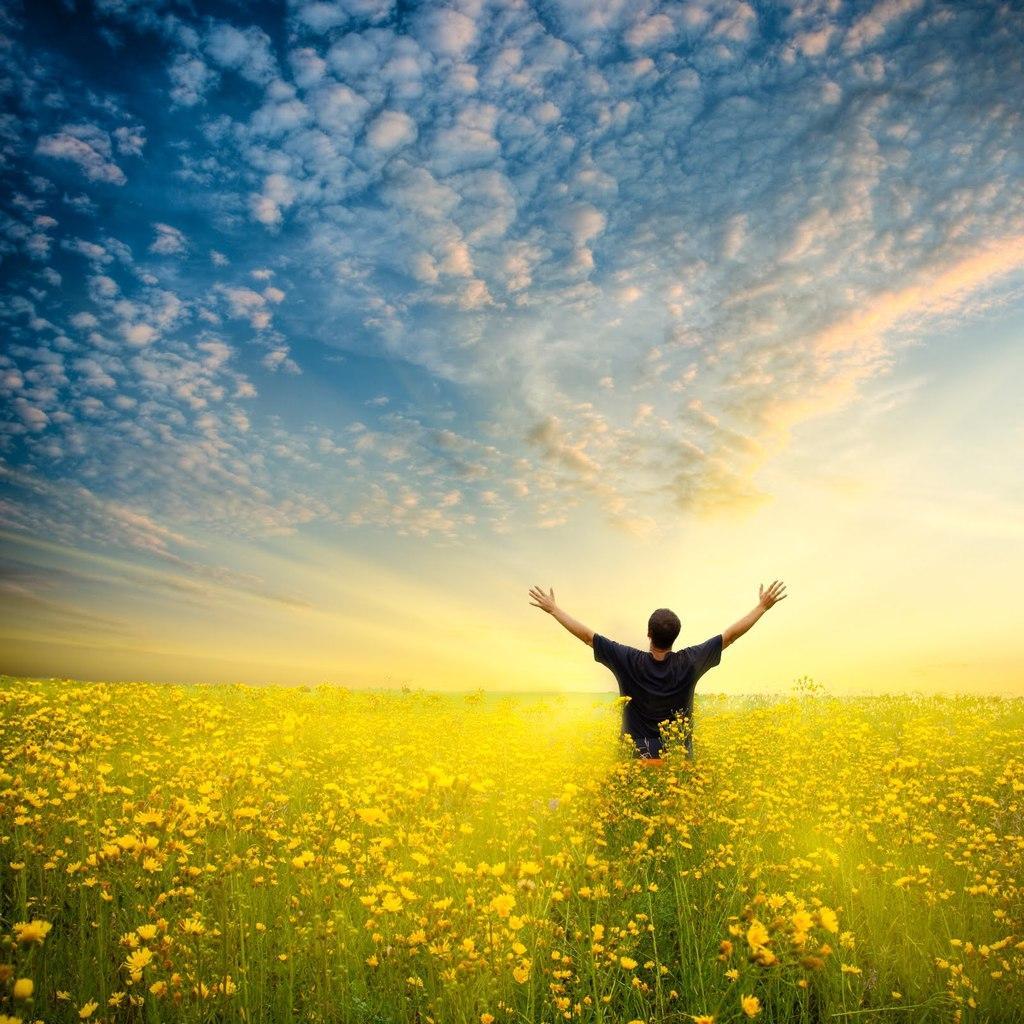Please provide a concise description of this image. In this image in the center there is one man who is standing, at the bottom there are some plants and flowers. On the top of the image there is sky. 